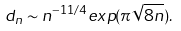Convert formula to latex. <formula><loc_0><loc_0><loc_500><loc_500>d _ { n } \sim n ^ { - 1 1 / 4 } e x p ( \pi \sqrt { 8 n } ) .</formula> 